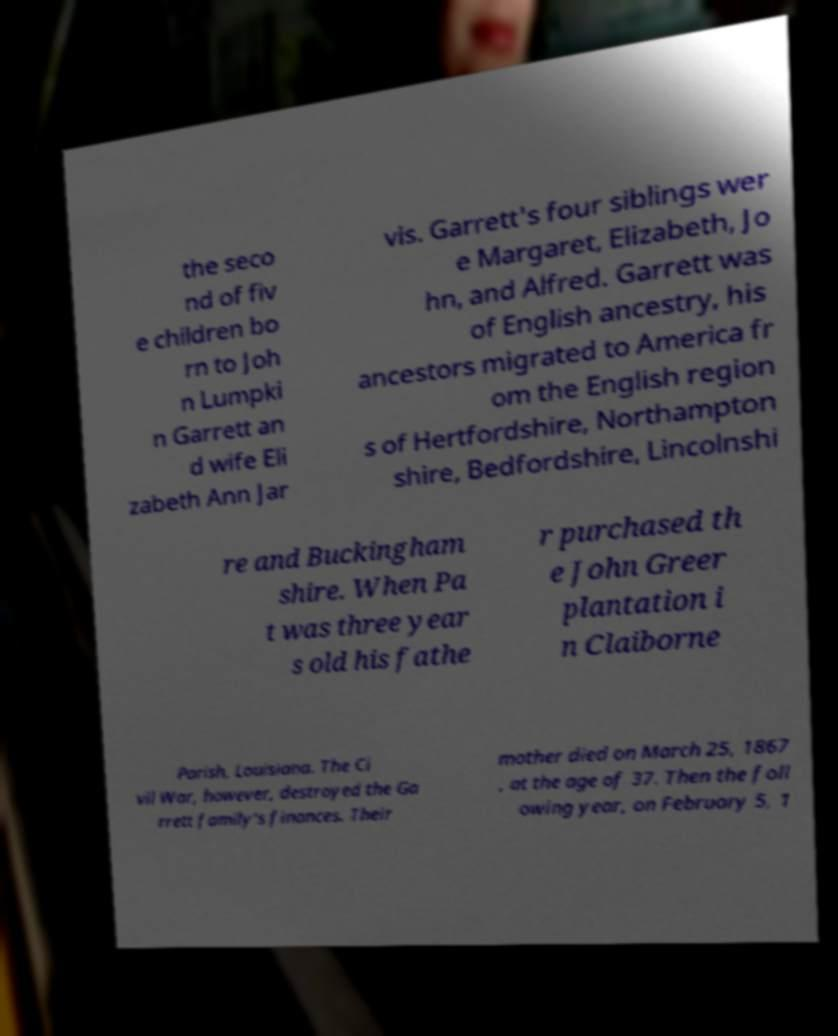What messages or text are displayed in this image? I need them in a readable, typed format. the seco nd of fiv e children bo rn to Joh n Lumpki n Garrett an d wife Eli zabeth Ann Jar vis. Garrett's four siblings wer e Margaret, Elizabeth, Jo hn, and Alfred. Garrett was of English ancestry, his ancestors migrated to America fr om the English region s of Hertfordshire, Northampton shire, Bedfordshire, Lincolnshi re and Buckingham shire. When Pa t was three year s old his fathe r purchased th e John Greer plantation i n Claiborne Parish, Louisiana. The Ci vil War, however, destroyed the Ga rrett family's finances. Their mother died on March 25, 1867 , at the age of 37. Then the foll owing year, on February 5, 1 